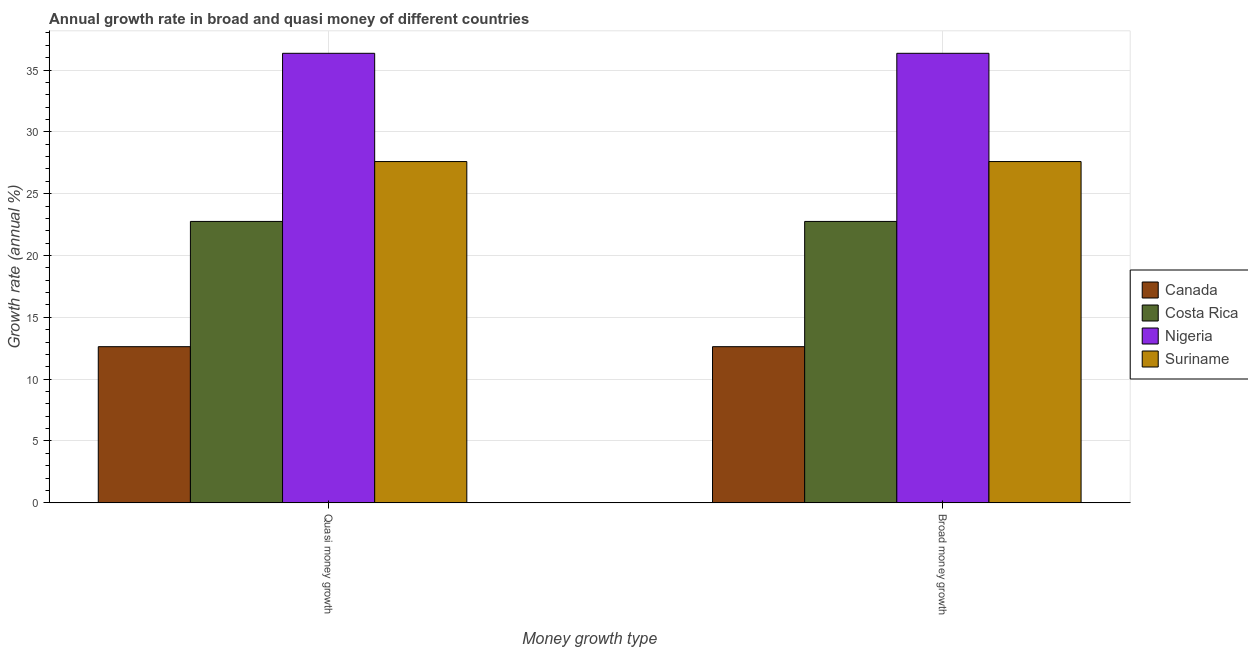How many different coloured bars are there?
Offer a terse response. 4. How many groups of bars are there?
Provide a short and direct response. 2. Are the number of bars per tick equal to the number of legend labels?
Give a very brief answer. Yes. How many bars are there on the 1st tick from the right?
Your response must be concise. 4. What is the label of the 2nd group of bars from the left?
Offer a very short reply. Broad money growth. What is the annual growth rate in broad money in Costa Rica?
Your response must be concise. 22.76. Across all countries, what is the maximum annual growth rate in quasi money?
Give a very brief answer. 36.35. Across all countries, what is the minimum annual growth rate in quasi money?
Keep it short and to the point. 12.63. In which country was the annual growth rate in quasi money maximum?
Give a very brief answer. Nigeria. In which country was the annual growth rate in quasi money minimum?
Offer a very short reply. Canada. What is the total annual growth rate in quasi money in the graph?
Offer a terse response. 99.33. What is the difference between the annual growth rate in broad money in Nigeria and that in Costa Rica?
Ensure brevity in your answer.  13.6. What is the difference between the annual growth rate in quasi money in Suriname and the annual growth rate in broad money in Canada?
Offer a terse response. 14.97. What is the average annual growth rate in broad money per country?
Keep it short and to the point. 24.83. What is the difference between the annual growth rate in broad money and annual growth rate in quasi money in Costa Rica?
Provide a succinct answer. 0. What is the ratio of the annual growth rate in quasi money in Suriname to that in Nigeria?
Keep it short and to the point. 0.76. Is the annual growth rate in quasi money in Costa Rica less than that in Nigeria?
Your answer should be compact. Yes. In how many countries, is the annual growth rate in broad money greater than the average annual growth rate in broad money taken over all countries?
Your response must be concise. 2. What does the 2nd bar from the right in Quasi money growth represents?
Your answer should be very brief. Nigeria. Are all the bars in the graph horizontal?
Keep it short and to the point. No. How many countries are there in the graph?
Keep it short and to the point. 4. What is the difference between two consecutive major ticks on the Y-axis?
Ensure brevity in your answer.  5. Are the values on the major ticks of Y-axis written in scientific E-notation?
Offer a very short reply. No. Does the graph contain any zero values?
Give a very brief answer. No. How are the legend labels stacked?
Provide a short and direct response. Vertical. What is the title of the graph?
Keep it short and to the point. Annual growth rate in broad and quasi money of different countries. What is the label or title of the X-axis?
Your answer should be compact. Money growth type. What is the label or title of the Y-axis?
Provide a succinct answer. Growth rate (annual %). What is the Growth rate (annual %) of Canada in Quasi money growth?
Provide a succinct answer. 12.63. What is the Growth rate (annual %) in Costa Rica in Quasi money growth?
Offer a terse response. 22.76. What is the Growth rate (annual %) in Nigeria in Quasi money growth?
Your answer should be compact. 36.35. What is the Growth rate (annual %) of Suriname in Quasi money growth?
Your answer should be compact. 27.6. What is the Growth rate (annual %) in Canada in Broad money growth?
Give a very brief answer. 12.63. What is the Growth rate (annual %) of Costa Rica in Broad money growth?
Your answer should be very brief. 22.76. What is the Growth rate (annual %) in Nigeria in Broad money growth?
Offer a terse response. 36.35. What is the Growth rate (annual %) in Suriname in Broad money growth?
Your answer should be compact. 27.6. Across all Money growth type, what is the maximum Growth rate (annual %) of Canada?
Your answer should be very brief. 12.63. Across all Money growth type, what is the maximum Growth rate (annual %) of Costa Rica?
Your response must be concise. 22.76. Across all Money growth type, what is the maximum Growth rate (annual %) in Nigeria?
Make the answer very short. 36.35. Across all Money growth type, what is the maximum Growth rate (annual %) of Suriname?
Offer a very short reply. 27.6. Across all Money growth type, what is the minimum Growth rate (annual %) in Canada?
Your answer should be very brief. 12.63. Across all Money growth type, what is the minimum Growth rate (annual %) in Costa Rica?
Make the answer very short. 22.76. Across all Money growth type, what is the minimum Growth rate (annual %) of Nigeria?
Your answer should be very brief. 36.35. Across all Money growth type, what is the minimum Growth rate (annual %) in Suriname?
Your answer should be very brief. 27.6. What is the total Growth rate (annual %) in Canada in the graph?
Offer a very short reply. 25.25. What is the total Growth rate (annual %) in Costa Rica in the graph?
Offer a terse response. 45.51. What is the total Growth rate (annual %) of Nigeria in the graph?
Give a very brief answer. 72.7. What is the total Growth rate (annual %) of Suriname in the graph?
Offer a very short reply. 55.19. What is the difference between the Growth rate (annual %) in Suriname in Quasi money growth and that in Broad money growth?
Provide a succinct answer. 0. What is the difference between the Growth rate (annual %) of Canada in Quasi money growth and the Growth rate (annual %) of Costa Rica in Broad money growth?
Offer a very short reply. -10.13. What is the difference between the Growth rate (annual %) in Canada in Quasi money growth and the Growth rate (annual %) in Nigeria in Broad money growth?
Provide a succinct answer. -23.73. What is the difference between the Growth rate (annual %) in Canada in Quasi money growth and the Growth rate (annual %) in Suriname in Broad money growth?
Keep it short and to the point. -14.97. What is the difference between the Growth rate (annual %) of Costa Rica in Quasi money growth and the Growth rate (annual %) of Nigeria in Broad money growth?
Give a very brief answer. -13.6. What is the difference between the Growth rate (annual %) in Costa Rica in Quasi money growth and the Growth rate (annual %) in Suriname in Broad money growth?
Provide a short and direct response. -4.84. What is the difference between the Growth rate (annual %) of Nigeria in Quasi money growth and the Growth rate (annual %) of Suriname in Broad money growth?
Ensure brevity in your answer.  8.75. What is the average Growth rate (annual %) in Canada per Money growth type?
Keep it short and to the point. 12.63. What is the average Growth rate (annual %) in Costa Rica per Money growth type?
Ensure brevity in your answer.  22.76. What is the average Growth rate (annual %) of Nigeria per Money growth type?
Keep it short and to the point. 36.35. What is the average Growth rate (annual %) of Suriname per Money growth type?
Your answer should be very brief. 27.6. What is the difference between the Growth rate (annual %) of Canada and Growth rate (annual %) of Costa Rica in Quasi money growth?
Your answer should be compact. -10.13. What is the difference between the Growth rate (annual %) in Canada and Growth rate (annual %) in Nigeria in Quasi money growth?
Offer a terse response. -23.73. What is the difference between the Growth rate (annual %) in Canada and Growth rate (annual %) in Suriname in Quasi money growth?
Keep it short and to the point. -14.97. What is the difference between the Growth rate (annual %) in Costa Rica and Growth rate (annual %) in Nigeria in Quasi money growth?
Provide a succinct answer. -13.6. What is the difference between the Growth rate (annual %) in Costa Rica and Growth rate (annual %) in Suriname in Quasi money growth?
Offer a terse response. -4.84. What is the difference between the Growth rate (annual %) of Nigeria and Growth rate (annual %) of Suriname in Quasi money growth?
Ensure brevity in your answer.  8.75. What is the difference between the Growth rate (annual %) in Canada and Growth rate (annual %) in Costa Rica in Broad money growth?
Ensure brevity in your answer.  -10.13. What is the difference between the Growth rate (annual %) in Canada and Growth rate (annual %) in Nigeria in Broad money growth?
Your answer should be very brief. -23.73. What is the difference between the Growth rate (annual %) in Canada and Growth rate (annual %) in Suriname in Broad money growth?
Provide a succinct answer. -14.97. What is the difference between the Growth rate (annual %) of Costa Rica and Growth rate (annual %) of Nigeria in Broad money growth?
Your response must be concise. -13.6. What is the difference between the Growth rate (annual %) of Costa Rica and Growth rate (annual %) of Suriname in Broad money growth?
Offer a terse response. -4.84. What is the difference between the Growth rate (annual %) of Nigeria and Growth rate (annual %) of Suriname in Broad money growth?
Offer a very short reply. 8.75. What is the ratio of the Growth rate (annual %) of Canada in Quasi money growth to that in Broad money growth?
Give a very brief answer. 1. What is the difference between the highest and the second highest Growth rate (annual %) of Costa Rica?
Provide a short and direct response. 0. What is the difference between the highest and the second highest Growth rate (annual %) of Suriname?
Your answer should be very brief. 0. What is the difference between the highest and the lowest Growth rate (annual %) in Canada?
Make the answer very short. 0. What is the difference between the highest and the lowest Growth rate (annual %) of Costa Rica?
Provide a succinct answer. 0. What is the difference between the highest and the lowest Growth rate (annual %) in Nigeria?
Provide a short and direct response. 0. What is the difference between the highest and the lowest Growth rate (annual %) of Suriname?
Keep it short and to the point. 0. 